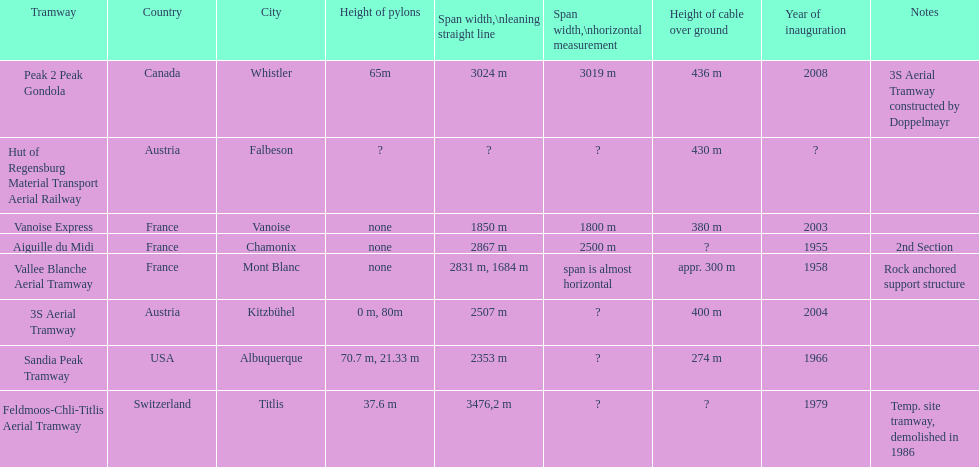How much further is the peak 2 peak gondola in comparison to the 32 aerial tramway? 517. 